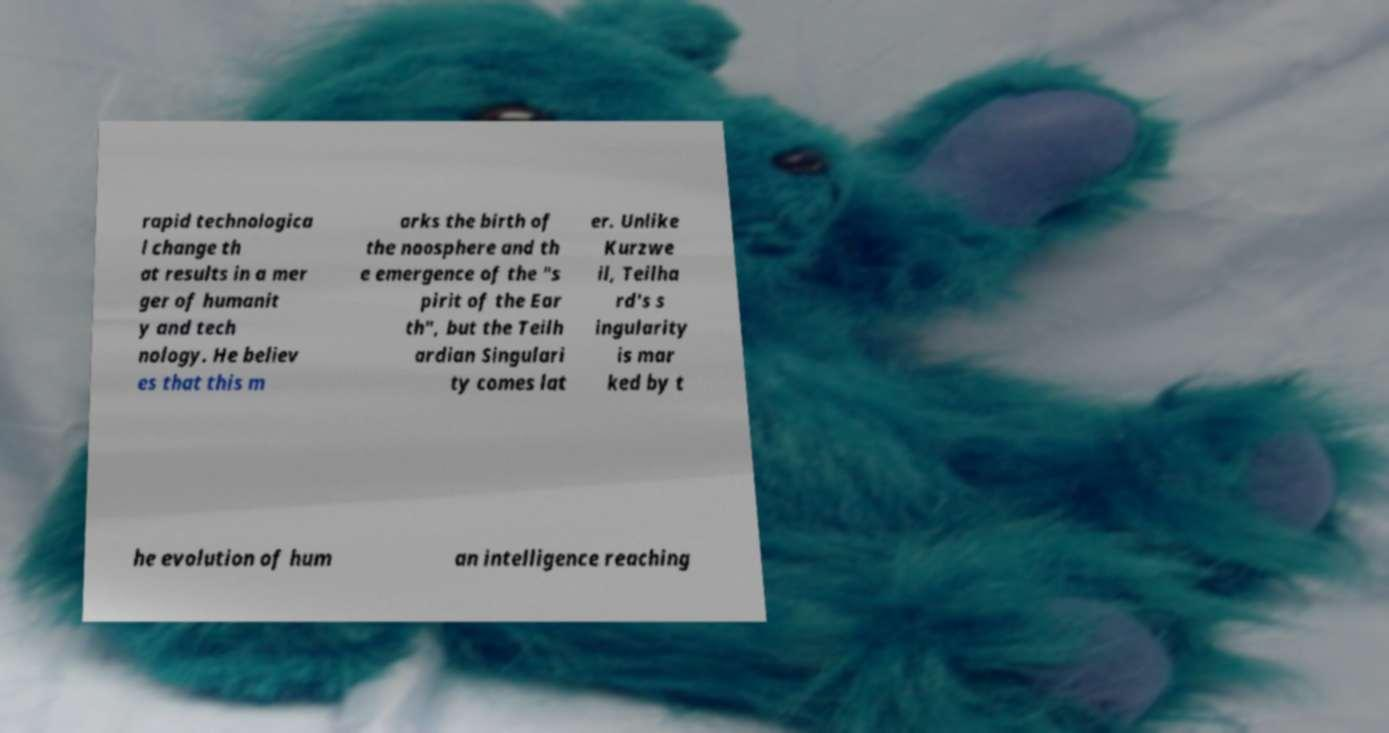Could you assist in decoding the text presented in this image and type it out clearly? rapid technologica l change th at results in a mer ger of humanit y and tech nology. He believ es that this m arks the birth of the noosphere and th e emergence of the "s pirit of the Ear th", but the Teilh ardian Singulari ty comes lat er. Unlike Kurzwe il, Teilha rd's s ingularity is mar ked by t he evolution of hum an intelligence reaching 